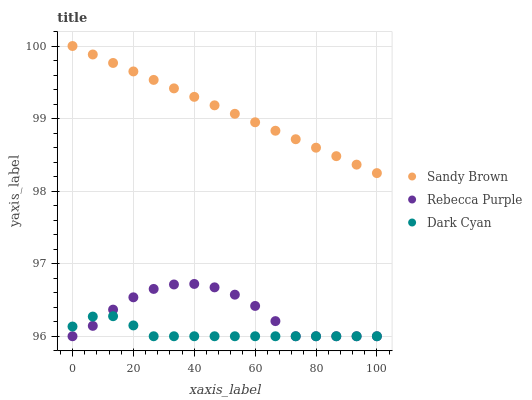Does Dark Cyan have the minimum area under the curve?
Answer yes or no. Yes. Does Sandy Brown have the maximum area under the curve?
Answer yes or no. Yes. Does Rebecca Purple have the minimum area under the curve?
Answer yes or no. No. Does Rebecca Purple have the maximum area under the curve?
Answer yes or no. No. Is Sandy Brown the smoothest?
Answer yes or no. Yes. Is Rebecca Purple the roughest?
Answer yes or no. Yes. Is Rebecca Purple the smoothest?
Answer yes or no. No. Is Sandy Brown the roughest?
Answer yes or no. No. Does Dark Cyan have the lowest value?
Answer yes or no. Yes. Does Sandy Brown have the lowest value?
Answer yes or no. No. Does Sandy Brown have the highest value?
Answer yes or no. Yes. Does Rebecca Purple have the highest value?
Answer yes or no. No. Is Rebecca Purple less than Sandy Brown?
Answer yes or no. Yes. Is Sandy Brown greater than Rebecca Purple?
Answer yes or no. Yes. Does Rebecca Purple intersect Dark Cyan?
Answer yes or no. Yes. Is Rebecca Purple less than Dark Cyan?
Answer yes or no. No. Is Rebecca Purple greater than Dark Cyan?
Answer yes or no. No. Does Rebecca Purple intersect Sandy Brown?
Answer yes or no. No. 